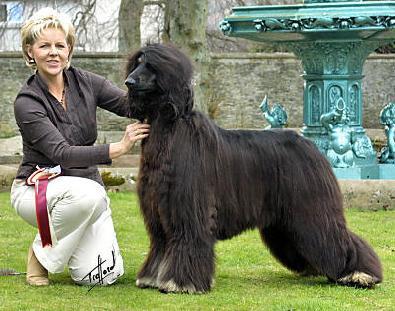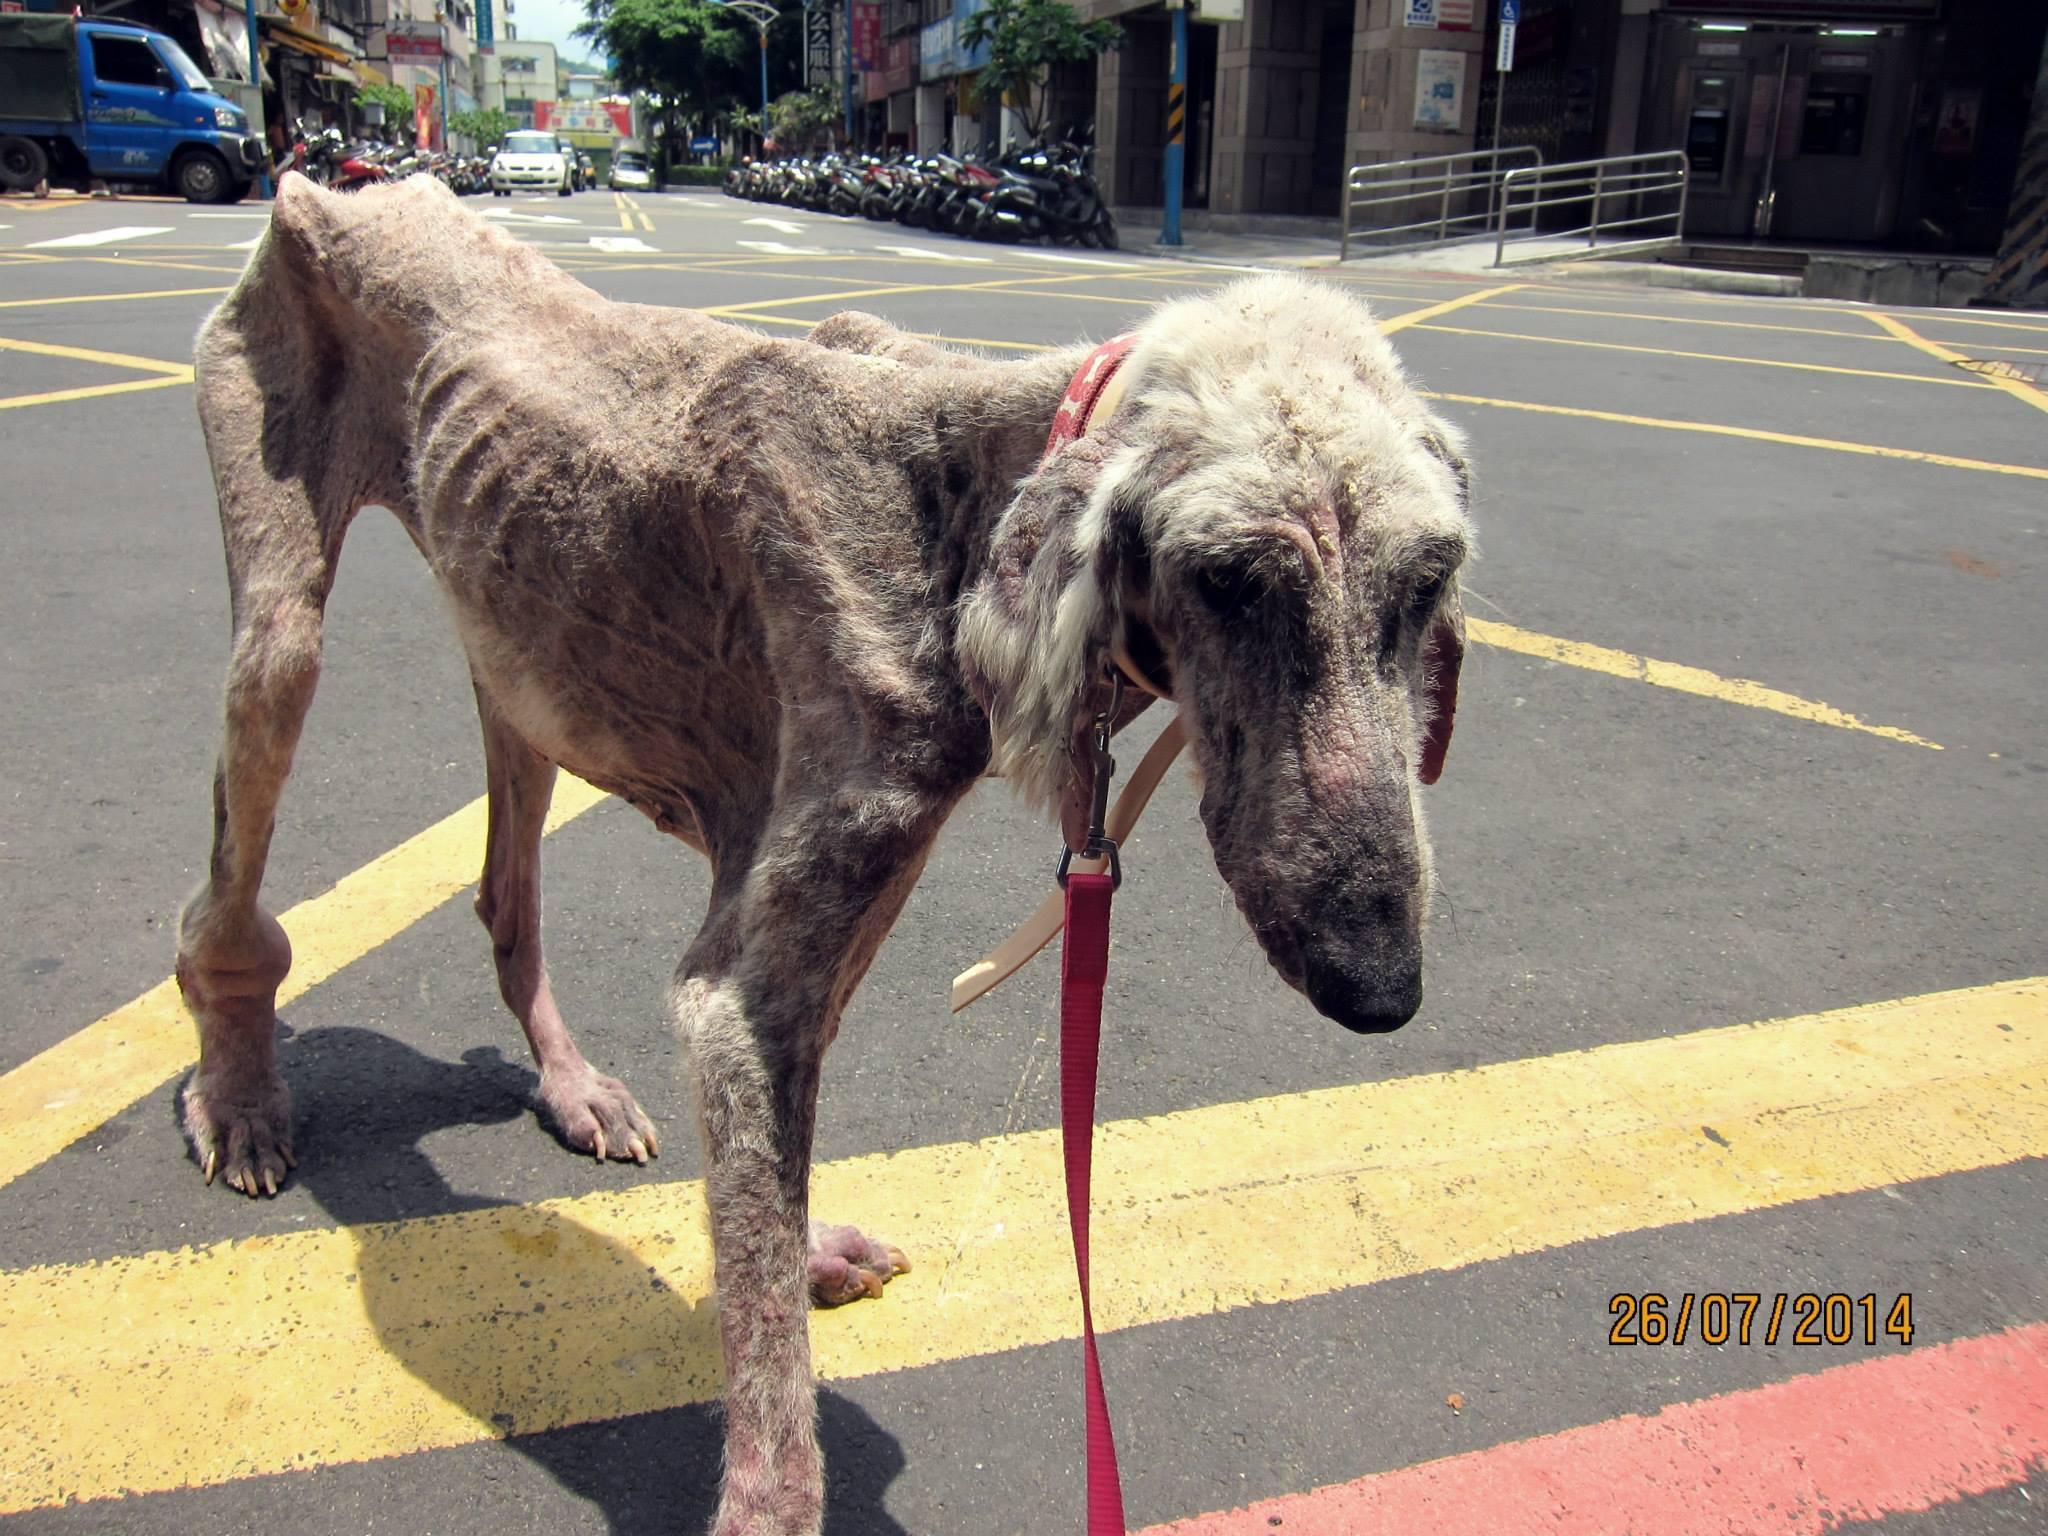The first image is the image on the left, the second image is the image on the right. Considering the images on both sides, is "A woman is on the left of an image, next to a dark afghan hound that stands in profile facing leftward." valid? Answer yes or no. Yes. The first image is the image on the left, the second image is the image on the right. Assess this claim about the two images: "The dog in the image in the right is standing on in the grass with a person.". Correct or not? Answer yes or no. No. 